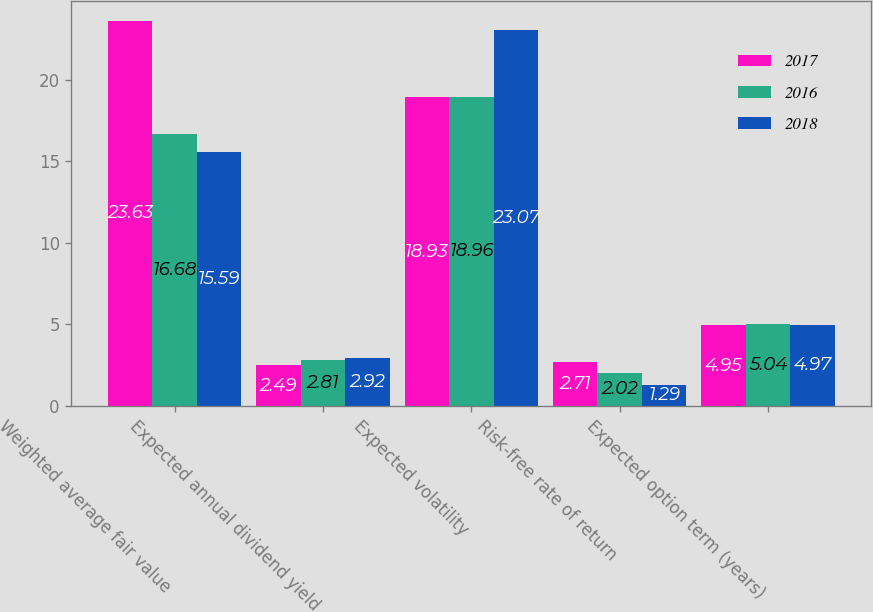<chart> <loc_0><loc_0><loc_500><loc_500><stacked_bar_chart><ecel><fcel>Weighted average fair value<fcel>Expected annual dividend yield<fcel>Expected volatility<fcel>Risk-free rate of return<fcel>Expected option term (years)<nl><fcel>2017<fcel>23.63<fcel>2.49<fcel>18.93<fcel>2.71<fcel>4.95<nl><fcel>2016<fcel>16.68<fcel>2.81<fcel>18.96<fcel>2.02<fcel>5.04<nl><fcel>2018<fcel>15.59<fcel>2.92<fcel>23.07<fcel>1.29<fcel>4.97<nl></chart> 